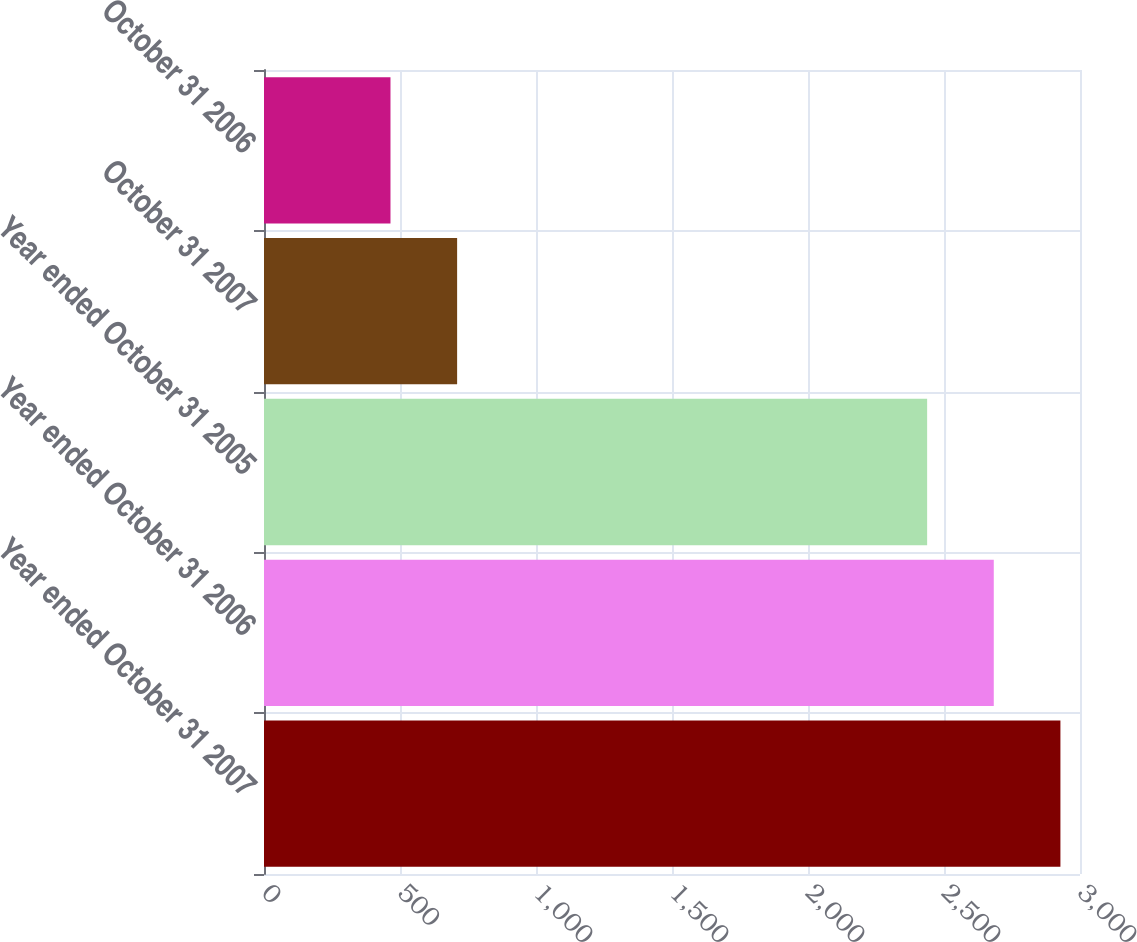Convert chart to OTSL. <chart><loc_0><loc_0><loc_500><loc_500><bar_chart><fcel>Year ended October 31 2007<fcel>Year ended October 31 2006<fcel>Year ended October 31 2005<fcel>October 31 2007<fcel>October 31 2006<nl><fcel>2928<fcel>2683<fcel>2438<fcel>710<fcel>465<nl></chart> 